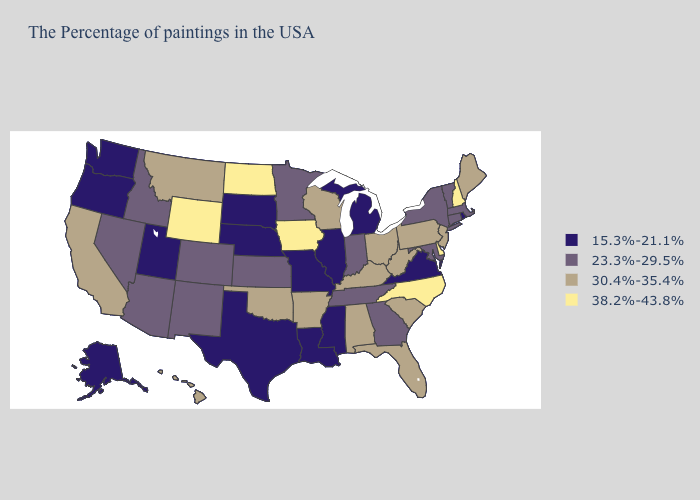What is the highest value in the Northeast ?
Write a very short answer. 38.2%-43.8%. What is the highest value in states that border Nevada?
Give a very brief answer. 30.4%-35.4%. What is the value of Mississippi?
Give a very brief answer. 15.3%-21.1%. Does Virginia have the lowest value in the South?
Answer briefly. Yes. Name the states that have a value in the range 30.4%-35.4%?
Keep it brief. Maine, New Jersey, Pennsylvania, South Carolina, West Virginia, Ohio, Florida, Kentucky, Alabama, Wisconsin, Arkansas, Oklahoma, Montana, California, Hawaii. What is the value of Indiana?
Keep it brief. 23.3%-29.5%. Among the states that border Colorado , does Wyoming have the highest value?
Answer briefly. Yes. Does Colorado have the lowest value in the USA?
Keep it brief. No. How many symbols are there in the legend?
Keep it brief. 4. What is the highest value in the South ?
Concise answer only. 38.2%-43.8%. Name the states that have a value in the range 15.3%-21.1%?
Give a very brief answer. Rhode Island, Virginia, Michigan, Illinois, Mississippi, Louisiana, Missouri, Nebraska, Texas, South Dakota, Utah, Washington, Oregon, Alaska. Name the states that have a value in the range 15.3%-21.1%?
Short answer required. Rhode Island, Virginia, Michigan, Illinois, Mississippi, Louisiana, Missouri, Nebraska, Texas, South Dakota, Utah, Washington, Oregon, Alaska. Name the states that have a value in the range 23.3%-29.5%?
Give a very brief answer. Massachusetts, Vermont, Connecticut, New York, Maryland, Georgia, Indiana, Tennessee, Minnesota, Kansas, Colorado, New Mexico, Arizona, Idaho, Nevada. Name the states that have a value in the range 30.4%-35.4%?
Keep it brief. Maine, New Jersey, Pennsylvania, South Carolina, West Virginia, Ohio, Florida, Kentucky, Alabama, Wisconsin, Arkansas, Oklahoma, Montana, California, Hawaii. Which states have the highest value in the USA?
Quick response, please. New Hampshire, Delaware, North Carolina, Iowa, North Dakota, Wyoming. 